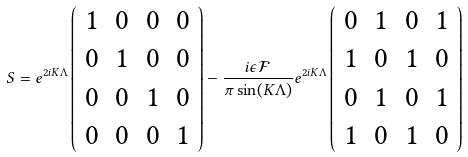Convert formula to latex. <formula><loc_0><loc_0><loc_500><loc_500>S = e ^ { 2 i K \Lambda } \left ( \begin{array} { c c c c } 1 & 0 & 0 & 0 \\ 0 & 1 & 0 & 0 \\ 0 & 0 & 1 & 0 \\ 0 & 0 & 0 & 1 \end{array} \right ) - \frac { i \epsilon \mathcal { F } } { \pi \sin ( K \Lambda ) } e ^ { 2 i K \Lambda } \left ( \begin{array} { c c c c } 0 & 1 & 0 & 1 \\ 1 & 0 & 1 & 0 \\ 0 & 1 & 0 & 1 \\ 1 & 0 & 1 & 0 \end{array} \right )</formula> 